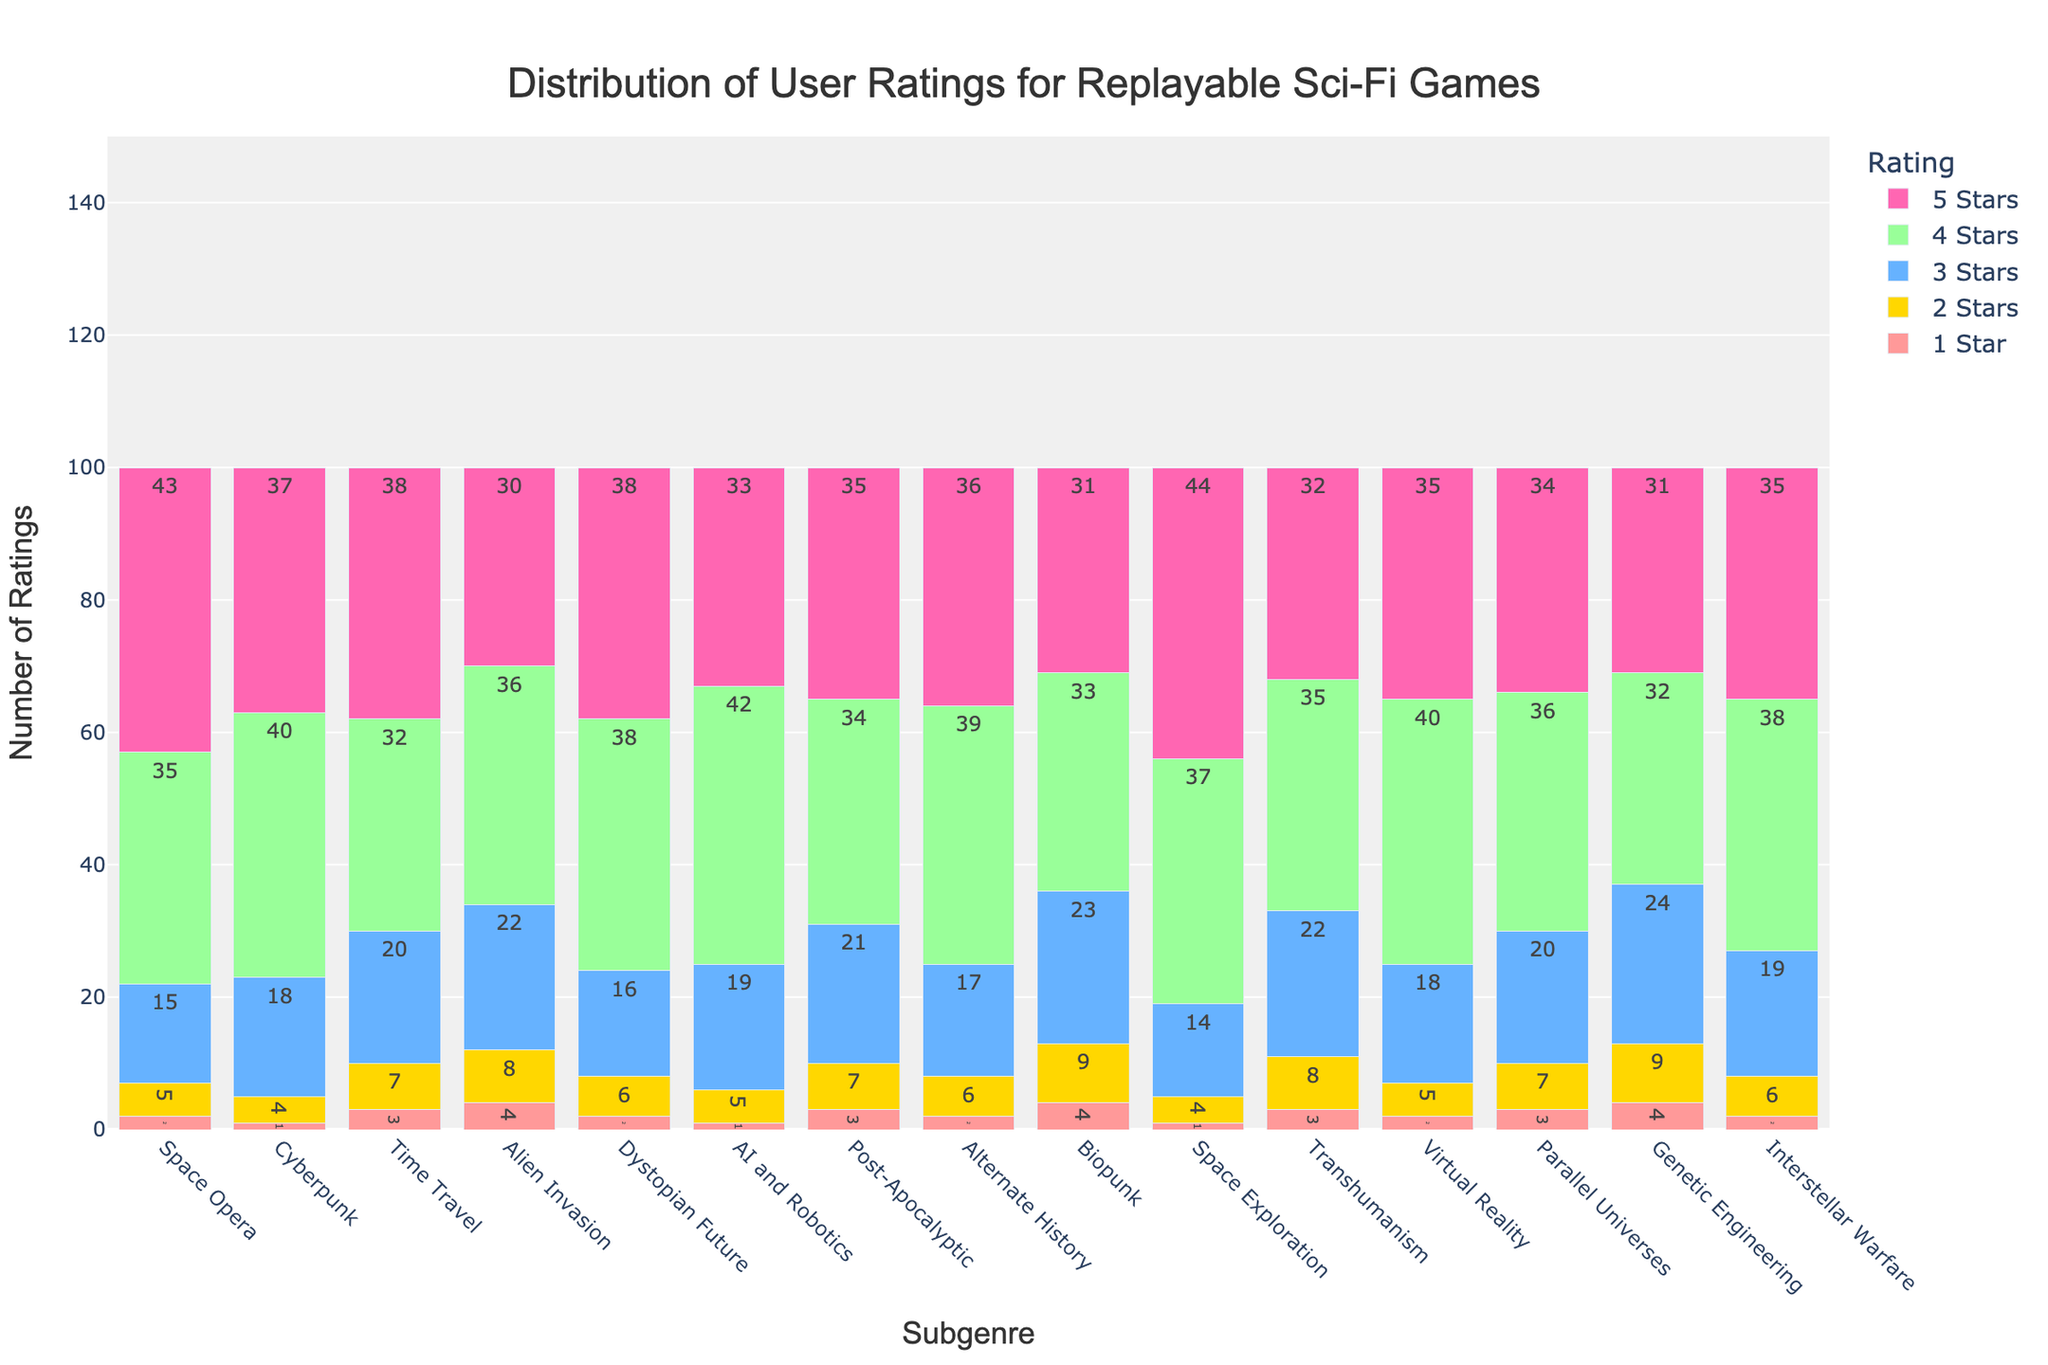What subgenre has the highest number of 5-star ratings? Look at the height of the 5-star rating bars and see which one is tallest. Space Exploration has the highest bar for 5 stars with 44 ratings.
Answer: Space Exploration Which subgenre has the lowest number of 1-star ratings? Look at the height of the 1-star rating bars and find the shortest one. Both Cyberpunk, AI and Robotics, and Space Exploration have the lowest number of 1-star ratings with 1 each.
Answer: Cyberpunk, AI and Robotics, Space Exploration What is the total number of ratings for the Dystopian Future subgenre? Sum up the number of ratings across all star categories for Dystopian Future. Adding them: 2 + 6 + 16 + 38 + 38 = 100.
Answer: 100 How many more 4-star ratings does AI and Robotics have compared to Time Travel? Subtract the number of 4-star ratings of Time Travel from AI and Robotics. 42 (AI and Robotics) - 32 (Time Travel) = 10.
Answer: 10 What is the average number of 3-star ratings across all subgenres? Sum up the number of 3-star ratings across all subgenres and divide by the number of subgenres. (15 + 18 + 20 + 22 + 16 + 19 + 21 + 17 + 23 + 14 + 22 + 18 + 20 + 24 + 19) / 15 = 275 / 15 = approximately 18.33.
Answer: 18.33 Between Alien Invasion and Post-Apocalyptic subgenres, which has a higher total number of ratings? Sum the ratings for each subgenre and compare. Alien Invasion: 4 + 8 + 22 + 36 + 30 = 100, Post-Apocalyptic: 3 + 7 + 21 + 34 + 35 = 100. Both have the same total number of ratings.
Answer: Both have the same How does the number of 2-star ratings for Biopunk compare to the number of 1-star ratings for Genetic Engineering? Compare the heights of the respective bars. Biopunk has 9 ratings for 2 stars, while Genetic Engineering has 4 ratings for 1 star. 9 is greater than 4.
Answer: Biopunk is higher What is the total number of 1-star ratings across all subgenres? Sum the number of 1-star ratings for each subgenre. 2 + 1 + 3 + 4 + 2 + 1 + 3 + 2 + 4 + 1 + 3 + 2 + 3 + 4 + 2 = 39.
Answer: 39 